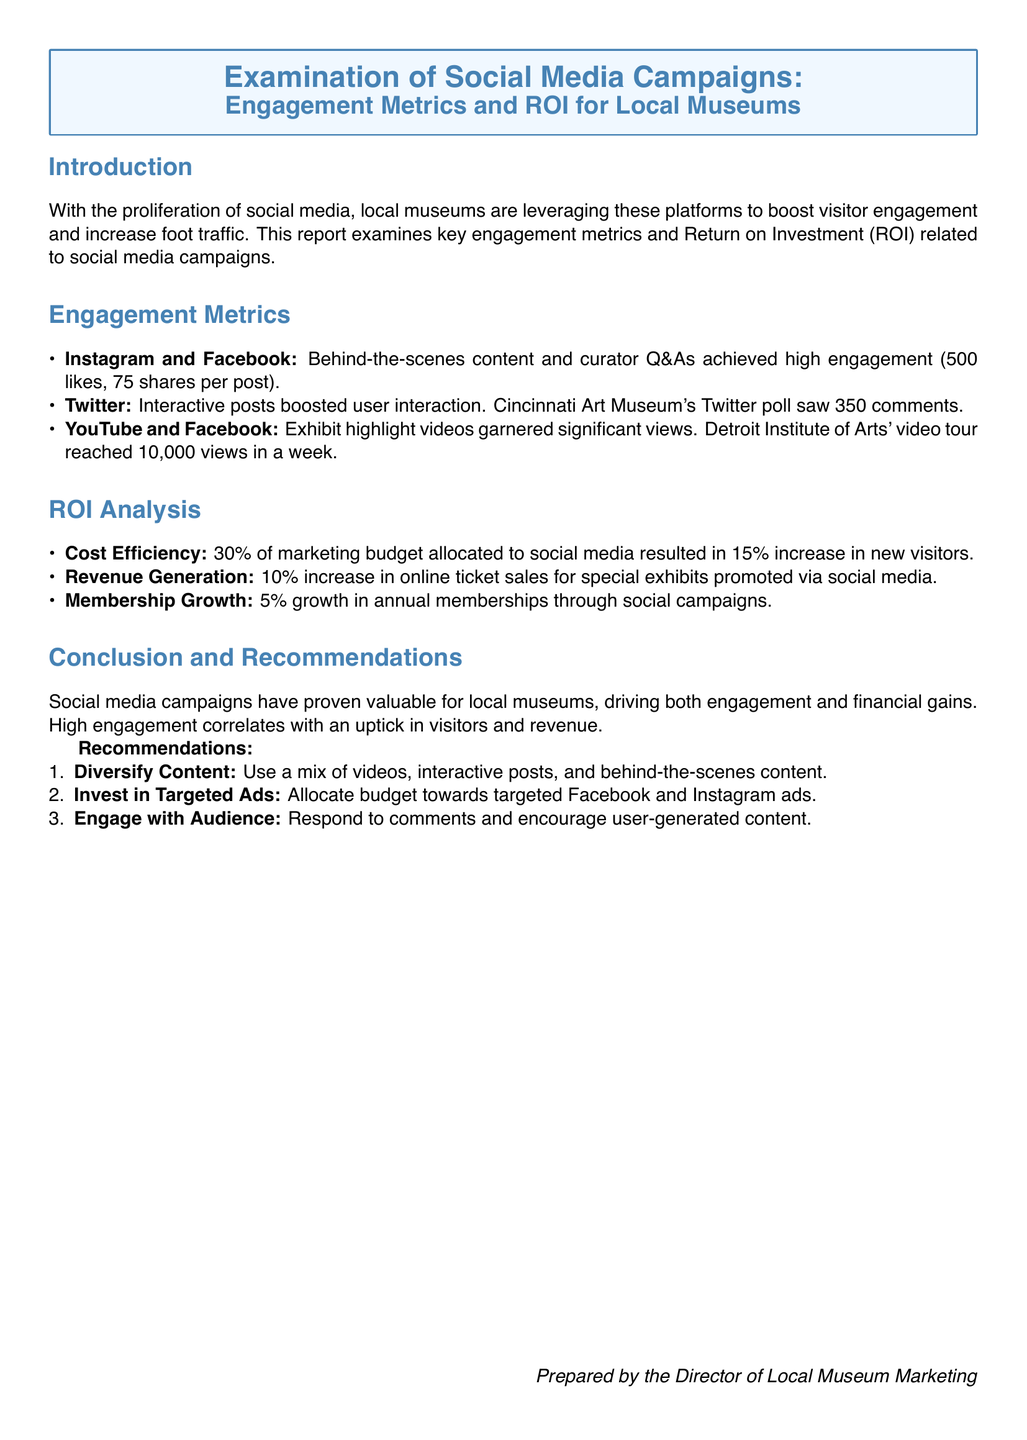what was the engagement metric for Instagram and Facebook? The document states that behind-the-scenes content and curator Q&As achieved high engagement with 500 likes and 75 shares per post.
Answer: 500 likes, 75 shares how many comments did the Cincinnati Art Museum's Twitter poll receive? It mentions that the Cincinnati Art Museum's Twitter poll saw 350 comments.
Answer: 350 comments what percentage of the marketing budget was allocated to social media? The report indicates that 30% of the marketing budget was allocated to social media.
Answer: 30% what percentage of new visitors was achieved through social media efforts? The document reports a 15% increase in new visitors as a result of social media.
Answer: 15% how many views did the Detroit Institute of Arts' video tour reach in a week? The document states that the Detroit Institute of Arts' video tour reached 10,000 views in a week.
Answer: 10,000 views what is one recommended strategy for engaging with the audience? The report suggests responding to comments and encouraging user-generated content as a strategy for engagement.
Answer: Respond to comments how much growth in annual memberships was reported from social campaigns? The report mentions a 5% growth in annual memberships through social campaigns.
Answer: 5% what type of content should be diversified according to the recommendations? The recommendations suggest using a mix of videos, interactive posts, and behind-the-scenes content.
Answer: Videos, interactive posts, behind-the-scenes content what is the document type of this report? The document is identified as a lab report examining social media campaigns for museums.
Answer: Lab report 